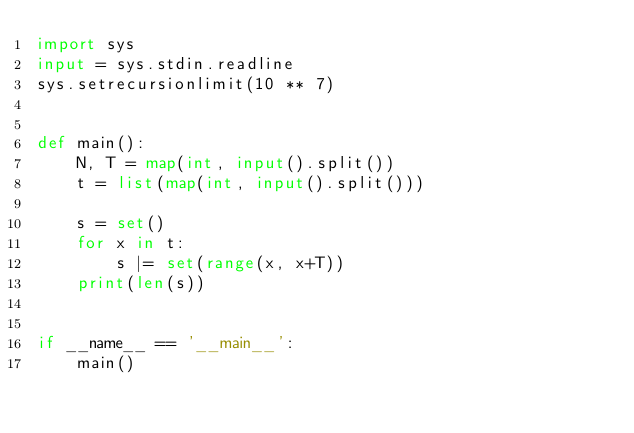Convert code to text. <code><loc_0><loc_0><loc_500><loc_500><_Python_>import sys
input = sys.stdin.readline
sys.setrecursionlimit(10 ** 7)


def main():
    N, T = map(int, input().split())
    t = list(map(int, input().split()))

    s = set()
    for x in t:
        s |= set(range(x, x+T))
    print(len(s))


if __name__ == '__main__':
    main()
</code> 